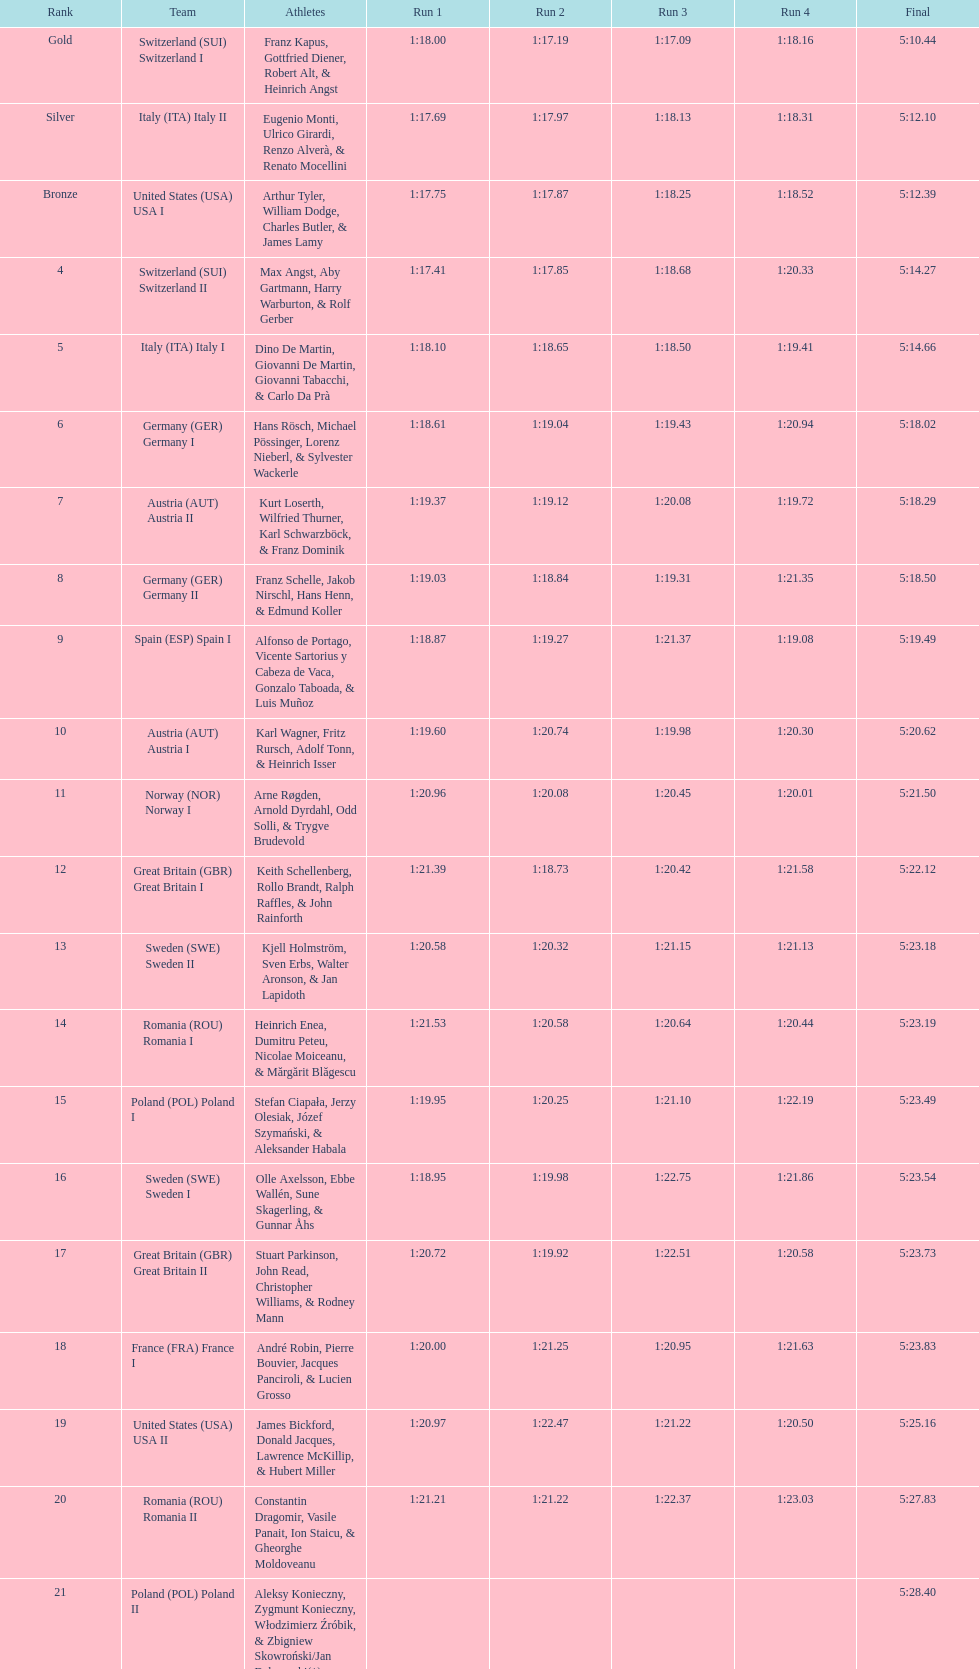What is the count of teams that germany had? 2. 